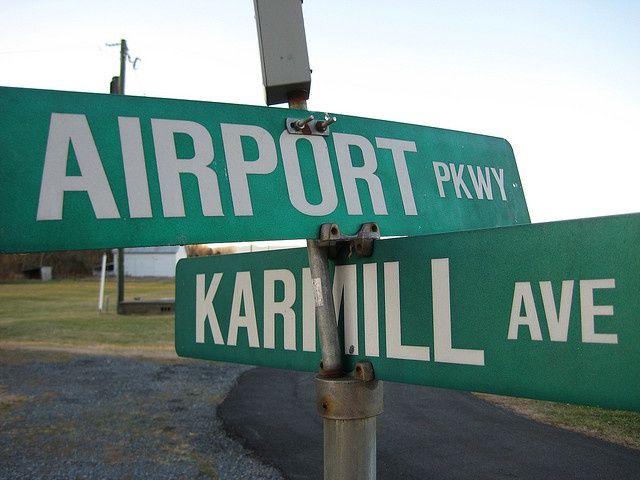Describe the objects in this image and their specific colors. I can see various objects in this image with different colors. 